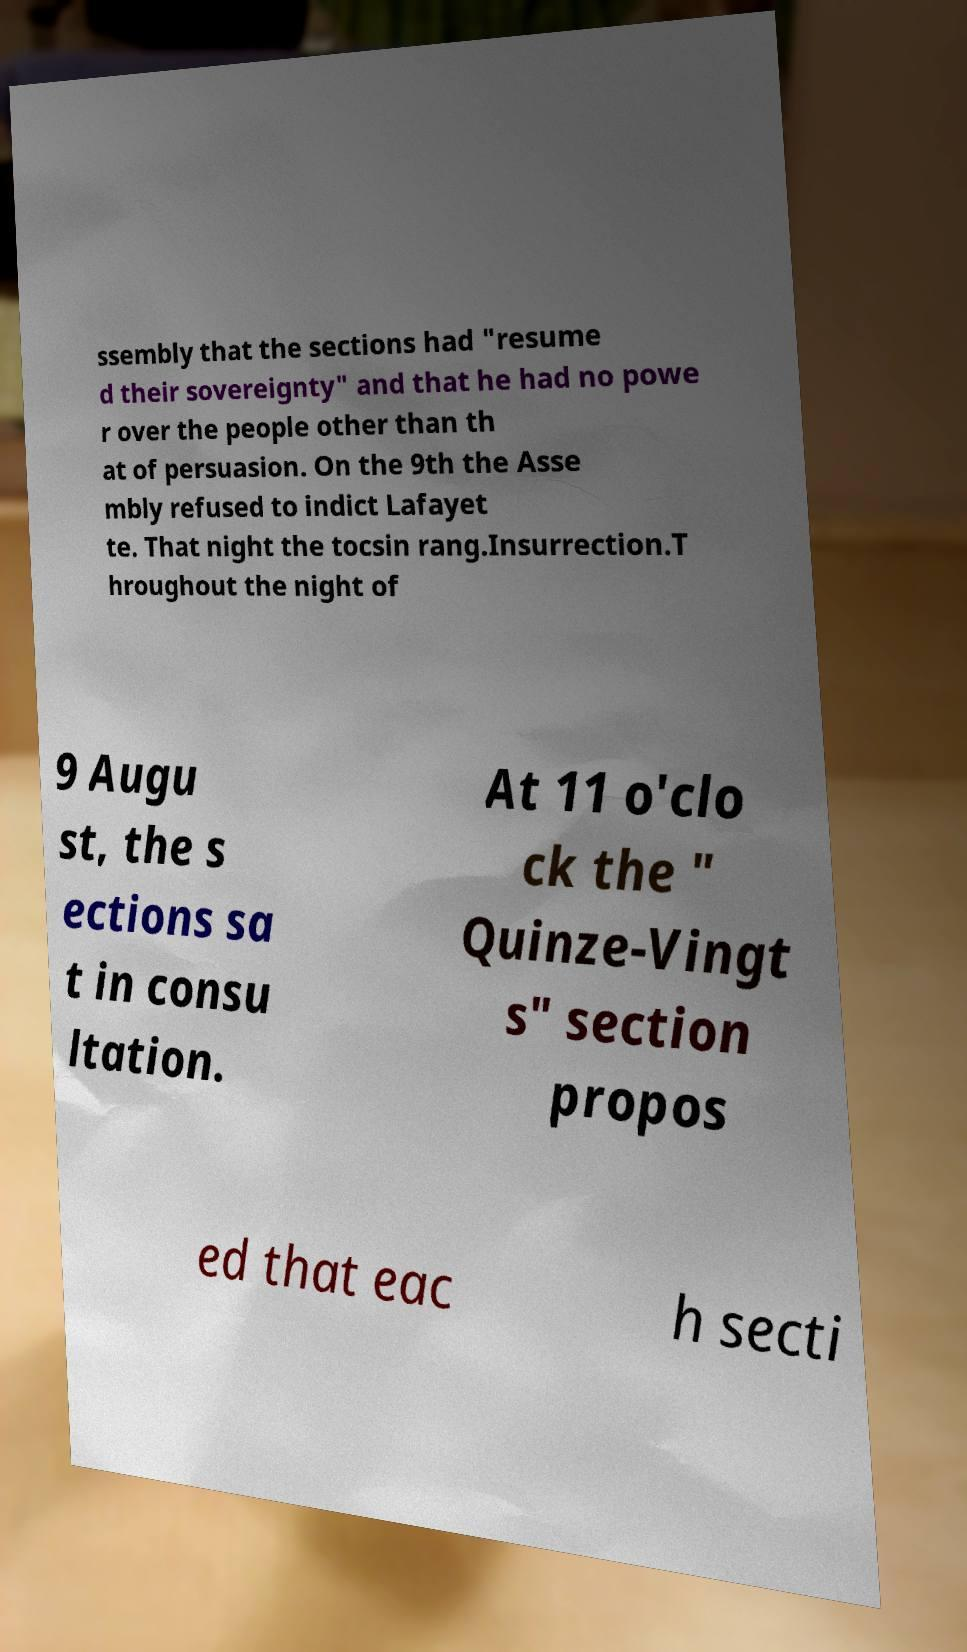There's text embedded in this image that I need extracted. Can you transcribe it verbatim? ssembly that the sections had "resume d their sovereignty" and that he had no powe r over the people other than th at of persuasion. On the 9th the Asse mbly refused to indict Lafayet te. That night the tocsin rang.Insurrection.T hroughout the night of 9 Augu st, the s ections sa t in consu ltation. At 11 o'clo ck the " Quinze-Vingt s" section propos ed that eac h secti 